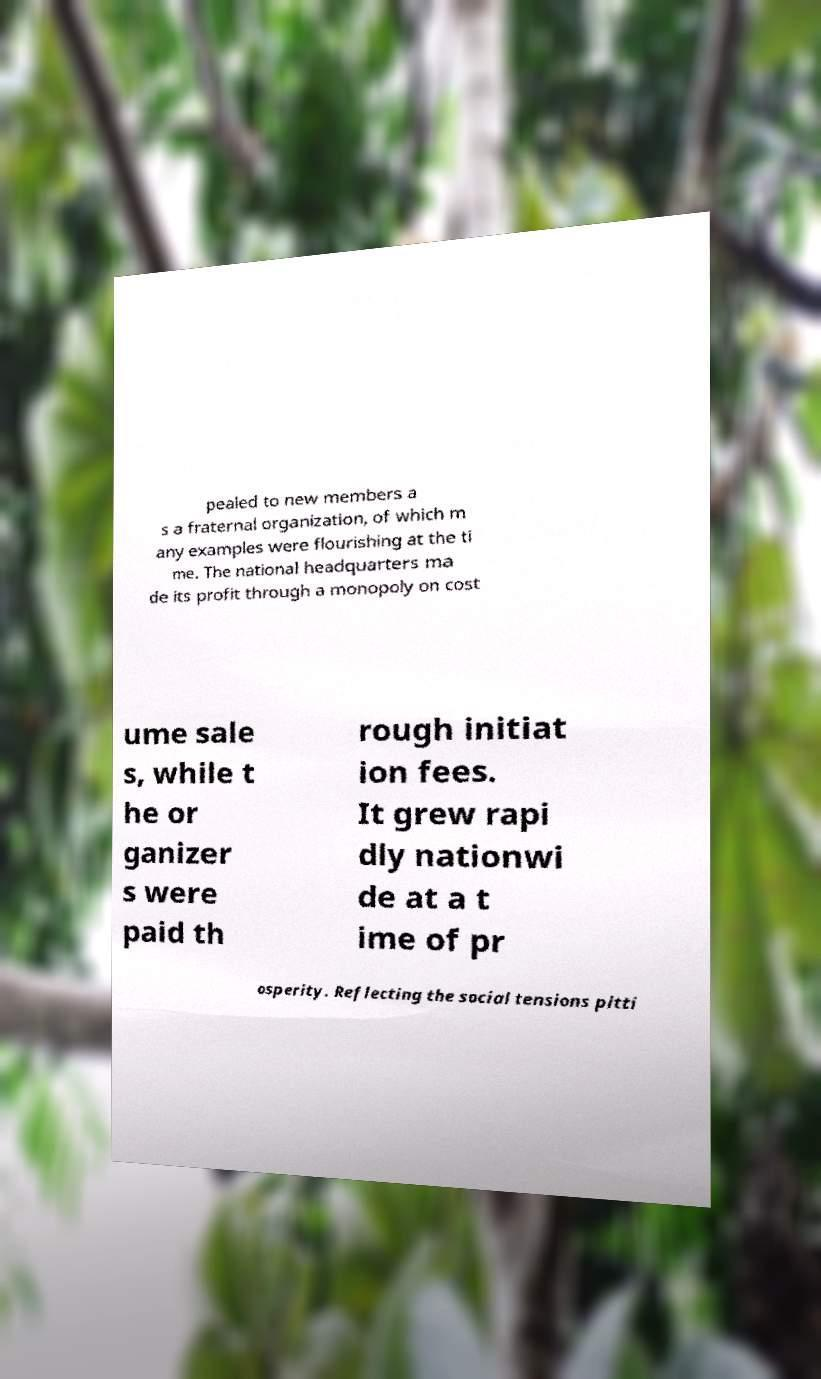Could you extract and type out the text from this image? pealed to new members a s a fraternal organization, of which m any examples were flourishing at the ti me. The national headquarters ma de its profit through a monopoly on cost ume sale s, while t he or ganizer s were paid th rough initiat ion fees. It grew rapi dly nationwi de at a t ime of pr osperity. Reflecting the social tensions pitti 